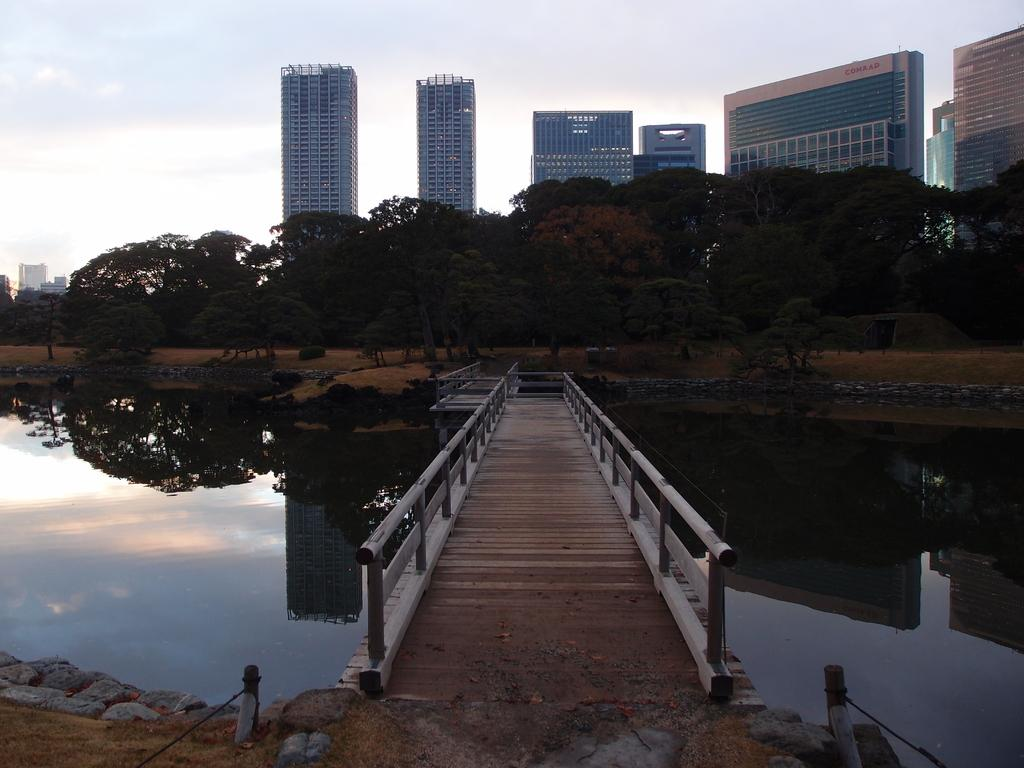What type of structure is in the image? There is a wooden bridge in the image. What are the small poles with ropes used for? The small poles with ropes are present in the image, but their purpose is not specified. What type of natural elements can be seen in the image? Stones are visible in the image. What can be seen in the background of the image? There are buildings and trees in the background of the image. What is visible in the sky in the image? The sky is visible in the image. How many pigs are visible on the wooden bridge in the image? There are no pigs present on the wooden bridge in the image. What type of paint is used on the buildings in the background? There is no information about the paint used on the buildings in the image. 